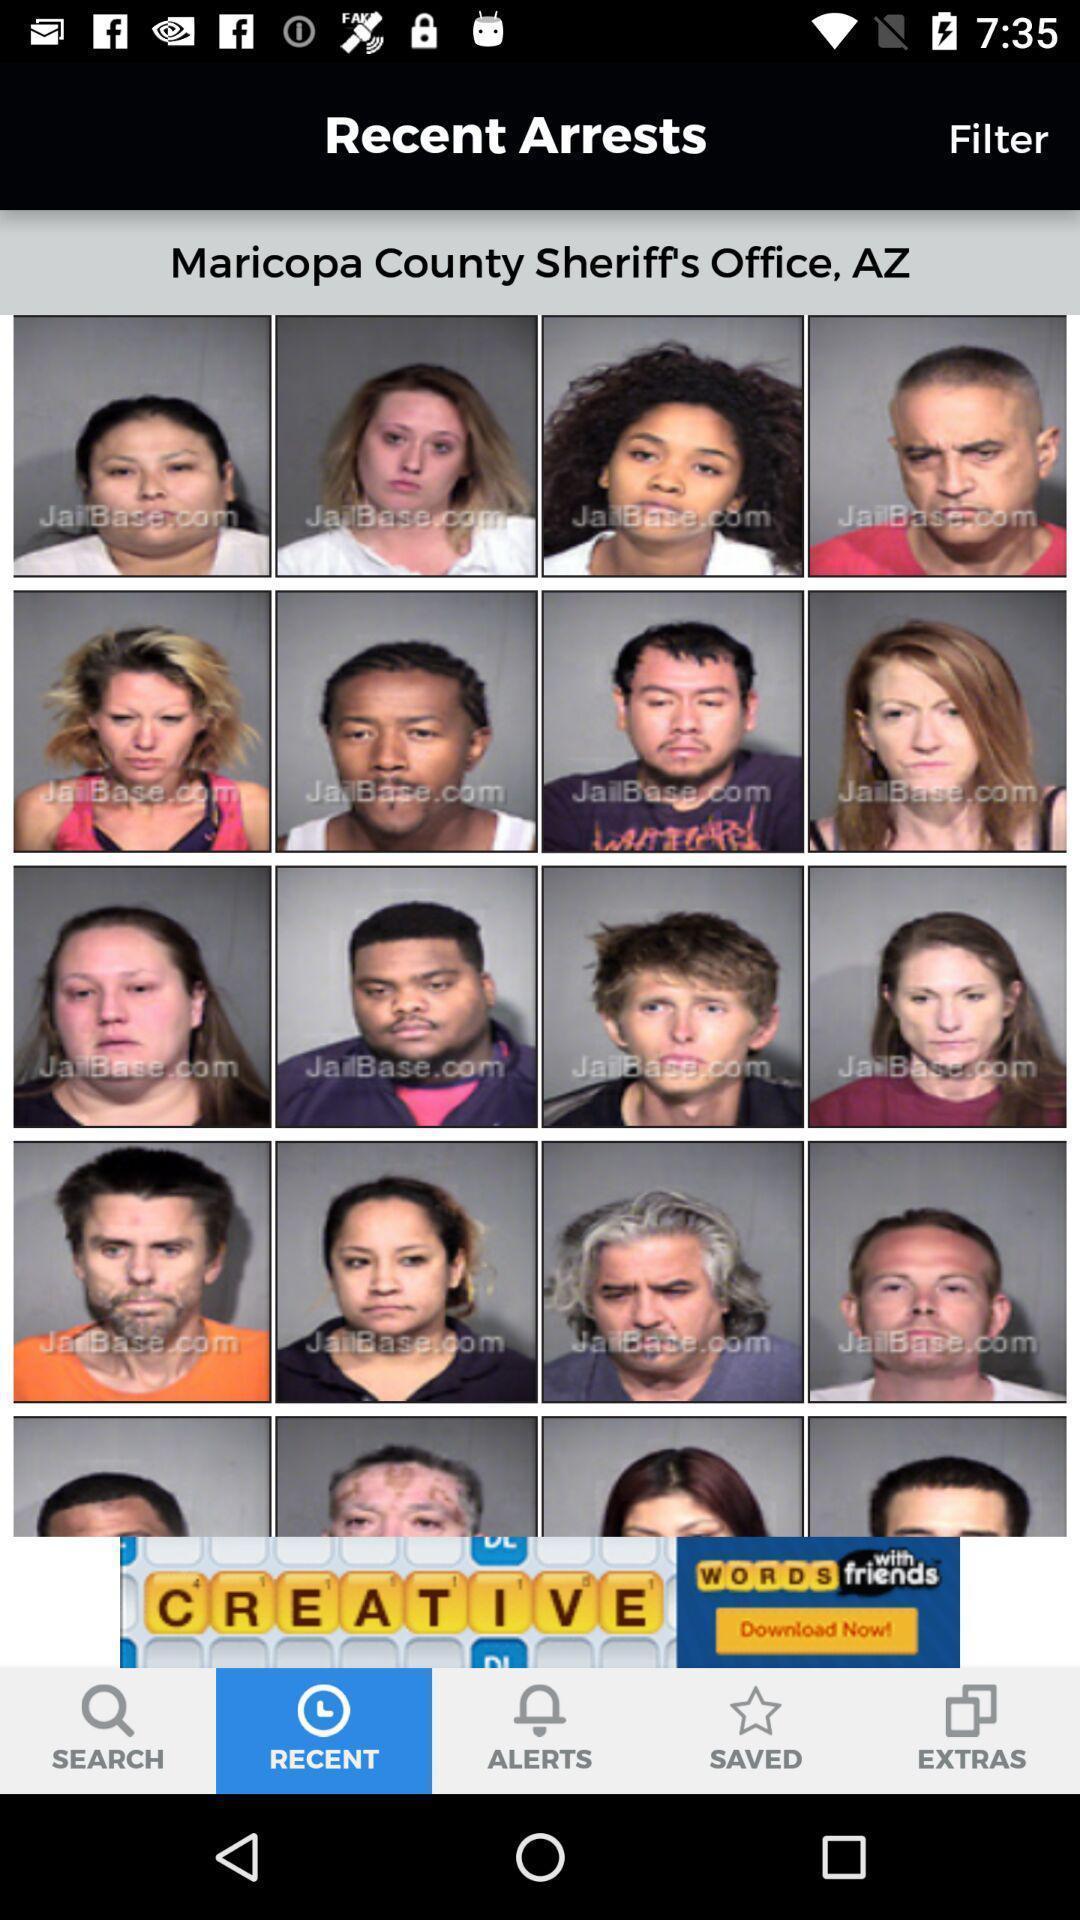Describe this image in words. Various images of convicts displayed. 